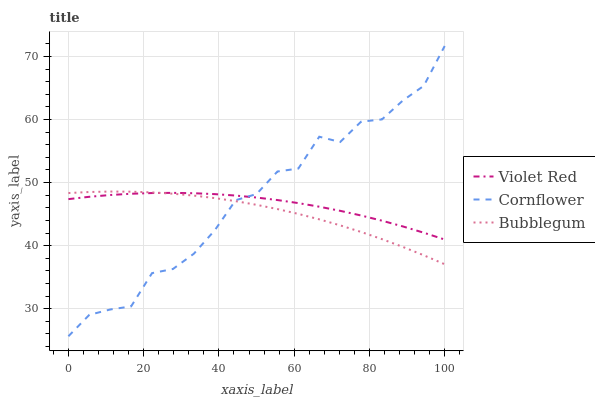Does Bubblegum have the minimum area under the curve?
Answer yes or no. Yes. Does Cornflower have the maximum area under the curve?
Answer yes or no. Yes. Does Violet Red have the minimum area under the curve?
Answer yes or no. No. Does Violet Red have the maximum area under the curve?
Answer yes or no. No. Is Violet Red the smoothest?
Answer yes or no. Yes. Is Cornflower the roughest?
Answer yes or no. Yes. Is Bubblegum the smoothest?
Answer yes or no. No. Is Bubblegum the roughest?
Answer yes or no. No. Does Bubblegum have the lowest value?
Answer yes or no. No. Does Cornflower have the highest value?
Answer yes or no. Yes. Does Bubblegum have the highest value?
Answer yes or no. No. Does Bubblegum intersect Cornflower?
Answer yes or no. Yes. Is Bubblegum less than Cornflower?
Answer yes or no. No. Is Bubblegum greater than Cornflower?
Answer yes or no. No. 